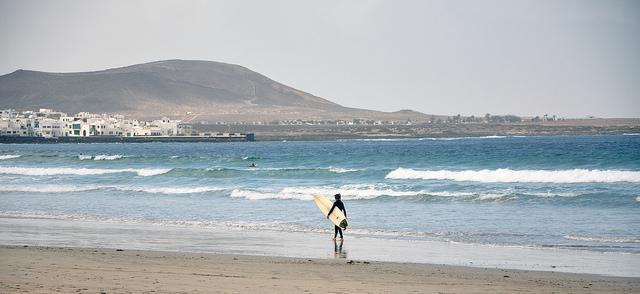How many boats are in the water?
Give a very brief answer. 0. How many sheep are grazing?
Give a very brief answer. 0. 